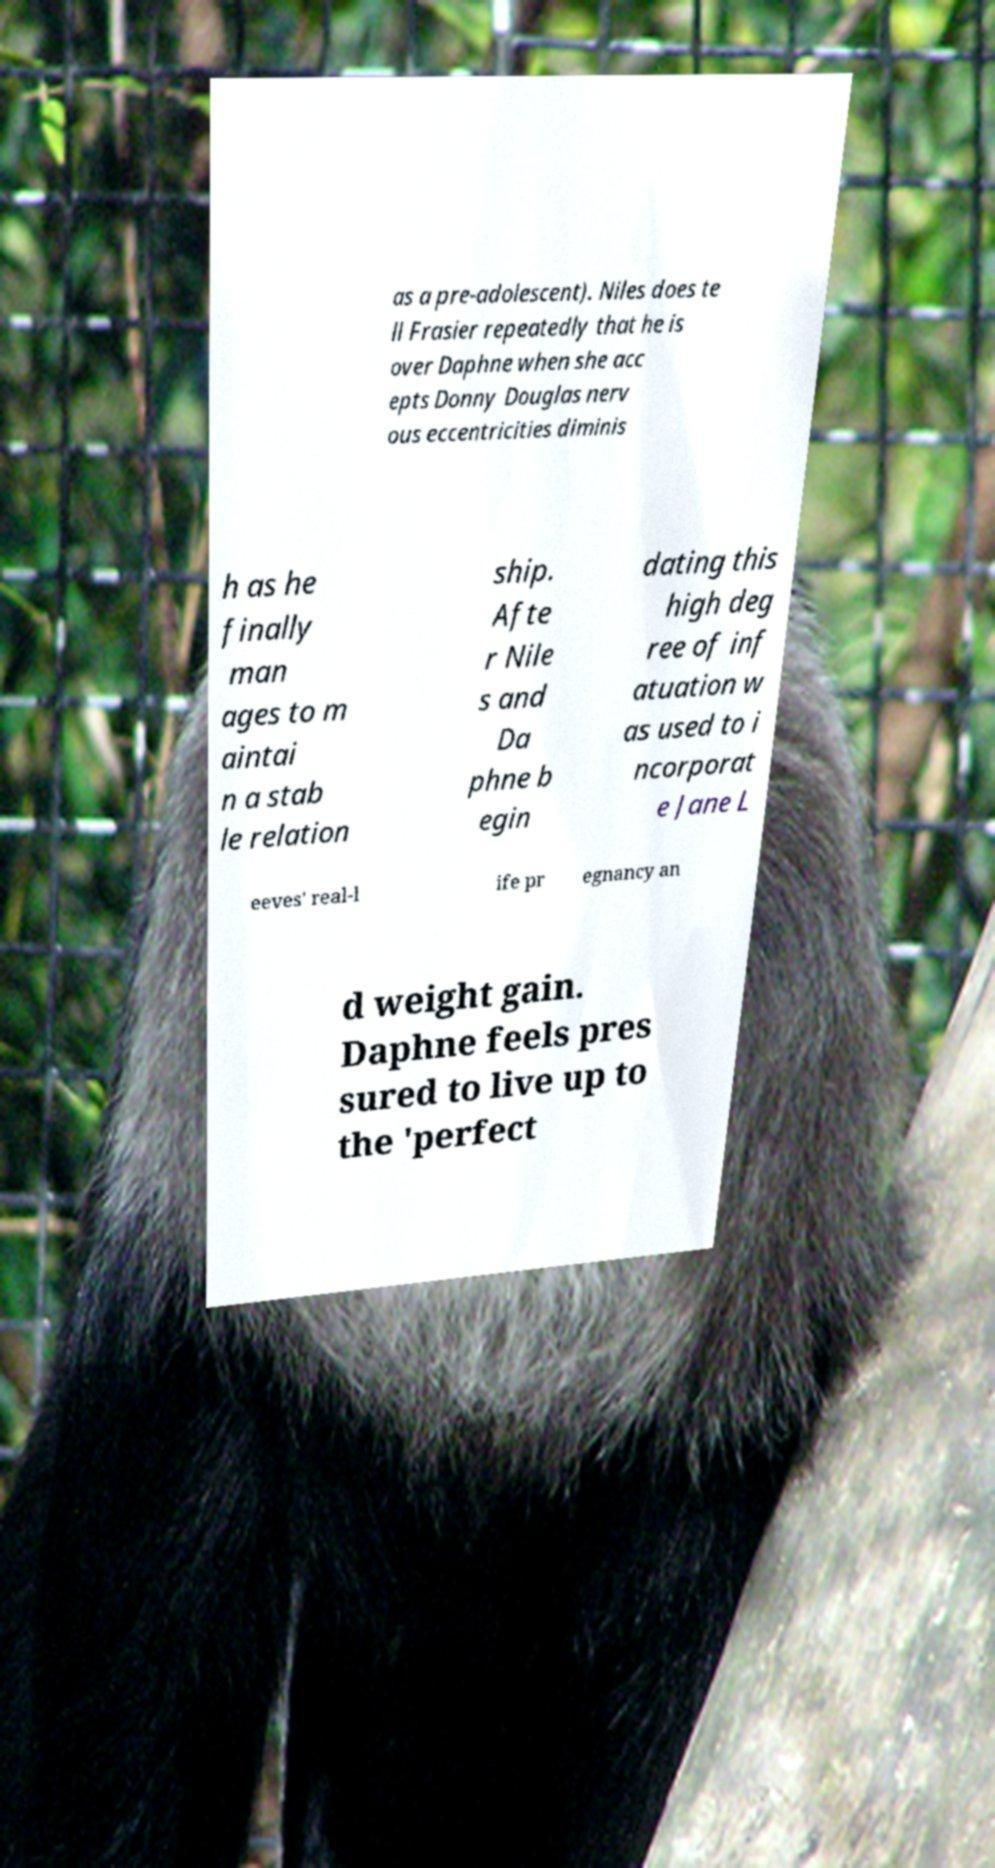What messages or text are displayed in this image? I need them in a readable, typed format. as a pre-adolescent). Niles does te ll Frasier repeatedly that he is over Daphne when she acc epts Donny Douglas nerv ous eccentricities diminis h as he finally man ages to m aintai n a stab le relation ship. Afte r Nile s and Da phne b egin dating this high deg ree of inf atuation w as used to i ncorporat e Jane L eeves' real-l ife pr egnancy an d weight gain. Daphne feels pres sured to live up to the 'perfect 